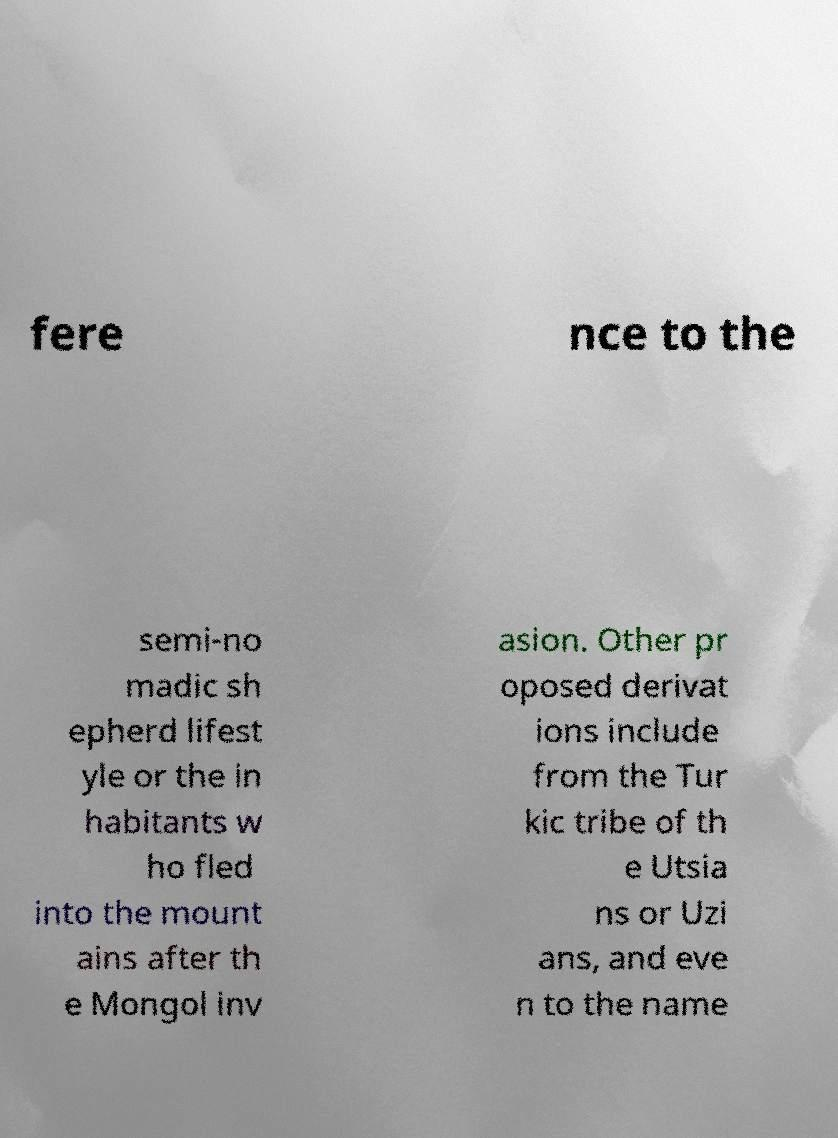Please identify and transcribe the text found in this image. fere nce to the semi-no madic sh epherd lifest yle or the in habitants w ho fled into the mount ains after th e Mongol inv asion. Other pr oposed derivat ions include from the Tur kic tribe of th e Utsia ns or Uzi ans, and eve n to the name 